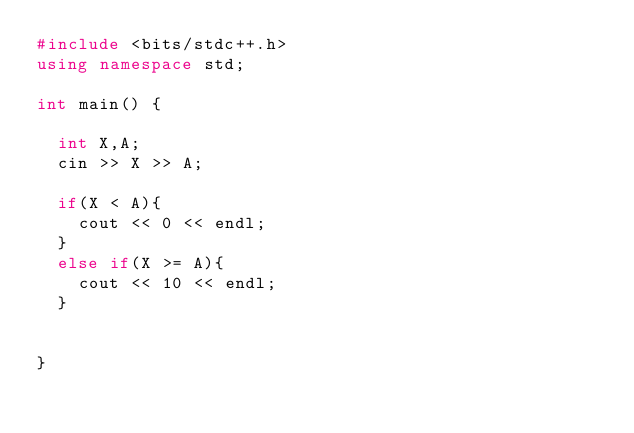Convert code to text. <code><loc_0><loc_0><loc_500><loc_500><_C++_>#include <bits/stdc++.h>
using namespace std;

int main() {
  
  int X,A;
  cin >> X >> A;
  
  if(X < A){
    cout << 0 << endl;
  }
  else if(X >= A){
    cout << 10 << endl;
  }
  
    
}</code> 